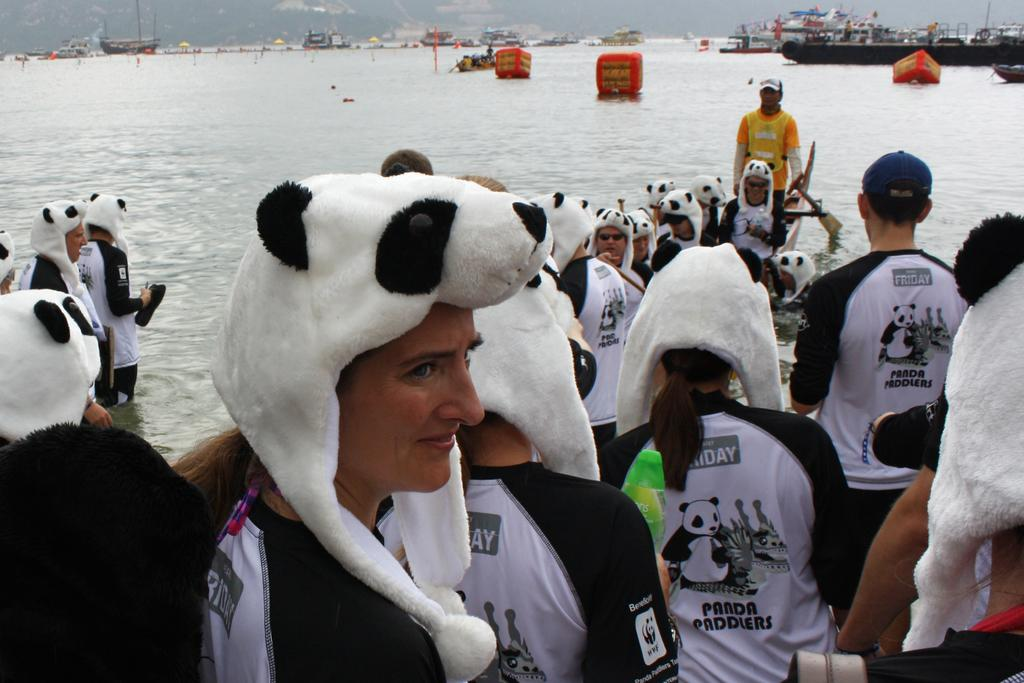Who or what is present in the image? There are people in the image. What are the people wearing on their heads? The people are wearing panda caps. What type of clothing are the people wearing? The people are wearing t-shirts. What can be seen in the background of the image? There is water visible in the image. What is in the water? There are boats in the water. What type of rice is being served on the property in the image? There is no rice or property present in the image; it features people wearing panda caps and t-shirts, as well as water and boats. How many rods can be seen in the image? There are no rods present in the image. 